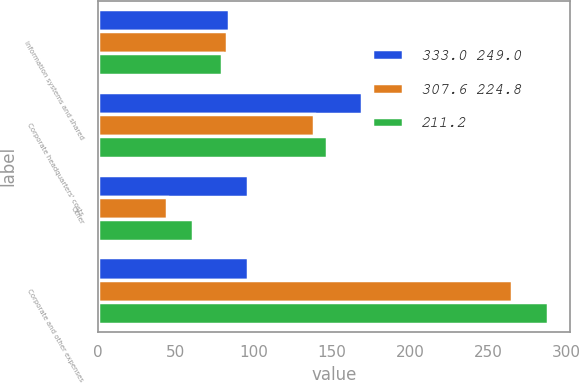Convert chart. <chart><loc_0><loc_0><loc_500><loc_500><stacked_bar_chart><ecel><fcel>Information systems and shared<fcel>Corporate headquarters' costs<fcel>Other<fcel>Corporate and other expenses<nl><fcel>333.0 249.0<fcel>84<fcel>169.1<fcel>96.2<fcel>96.2<nl><fcel>307.6 224.8<fcel>82.8<fcel>138.1<fcel>44.3<fcel>265.2<nl><fcel>211.2<fcel>79.7<fcel>146.9<fcel>61.3<fcel>287.9<nl></chart> 